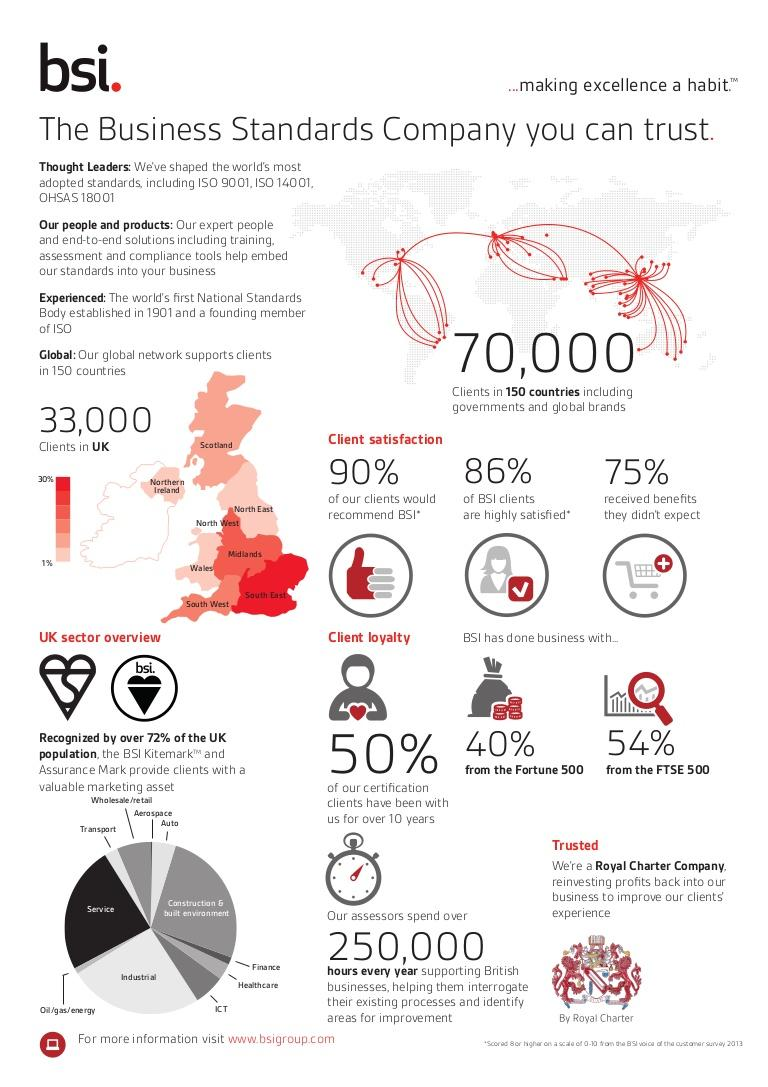List a handful of essential elements in this visual. According to client feedback, approximately 10% of clients would not recommend BSI. Approximately 14% of BSI clients do not fall into the highly satisfied category. According to the information provided, 25% of individuals did not receive benefits from the Barbados Statistical Institute (BSI). Ninety-nine percent of BSI's clients are based in the United Kingdom, with the remaining one percent coming from Northern Ireland, the North East, and Wales. BSI has 30% of its clients located in the UK's South East region. 